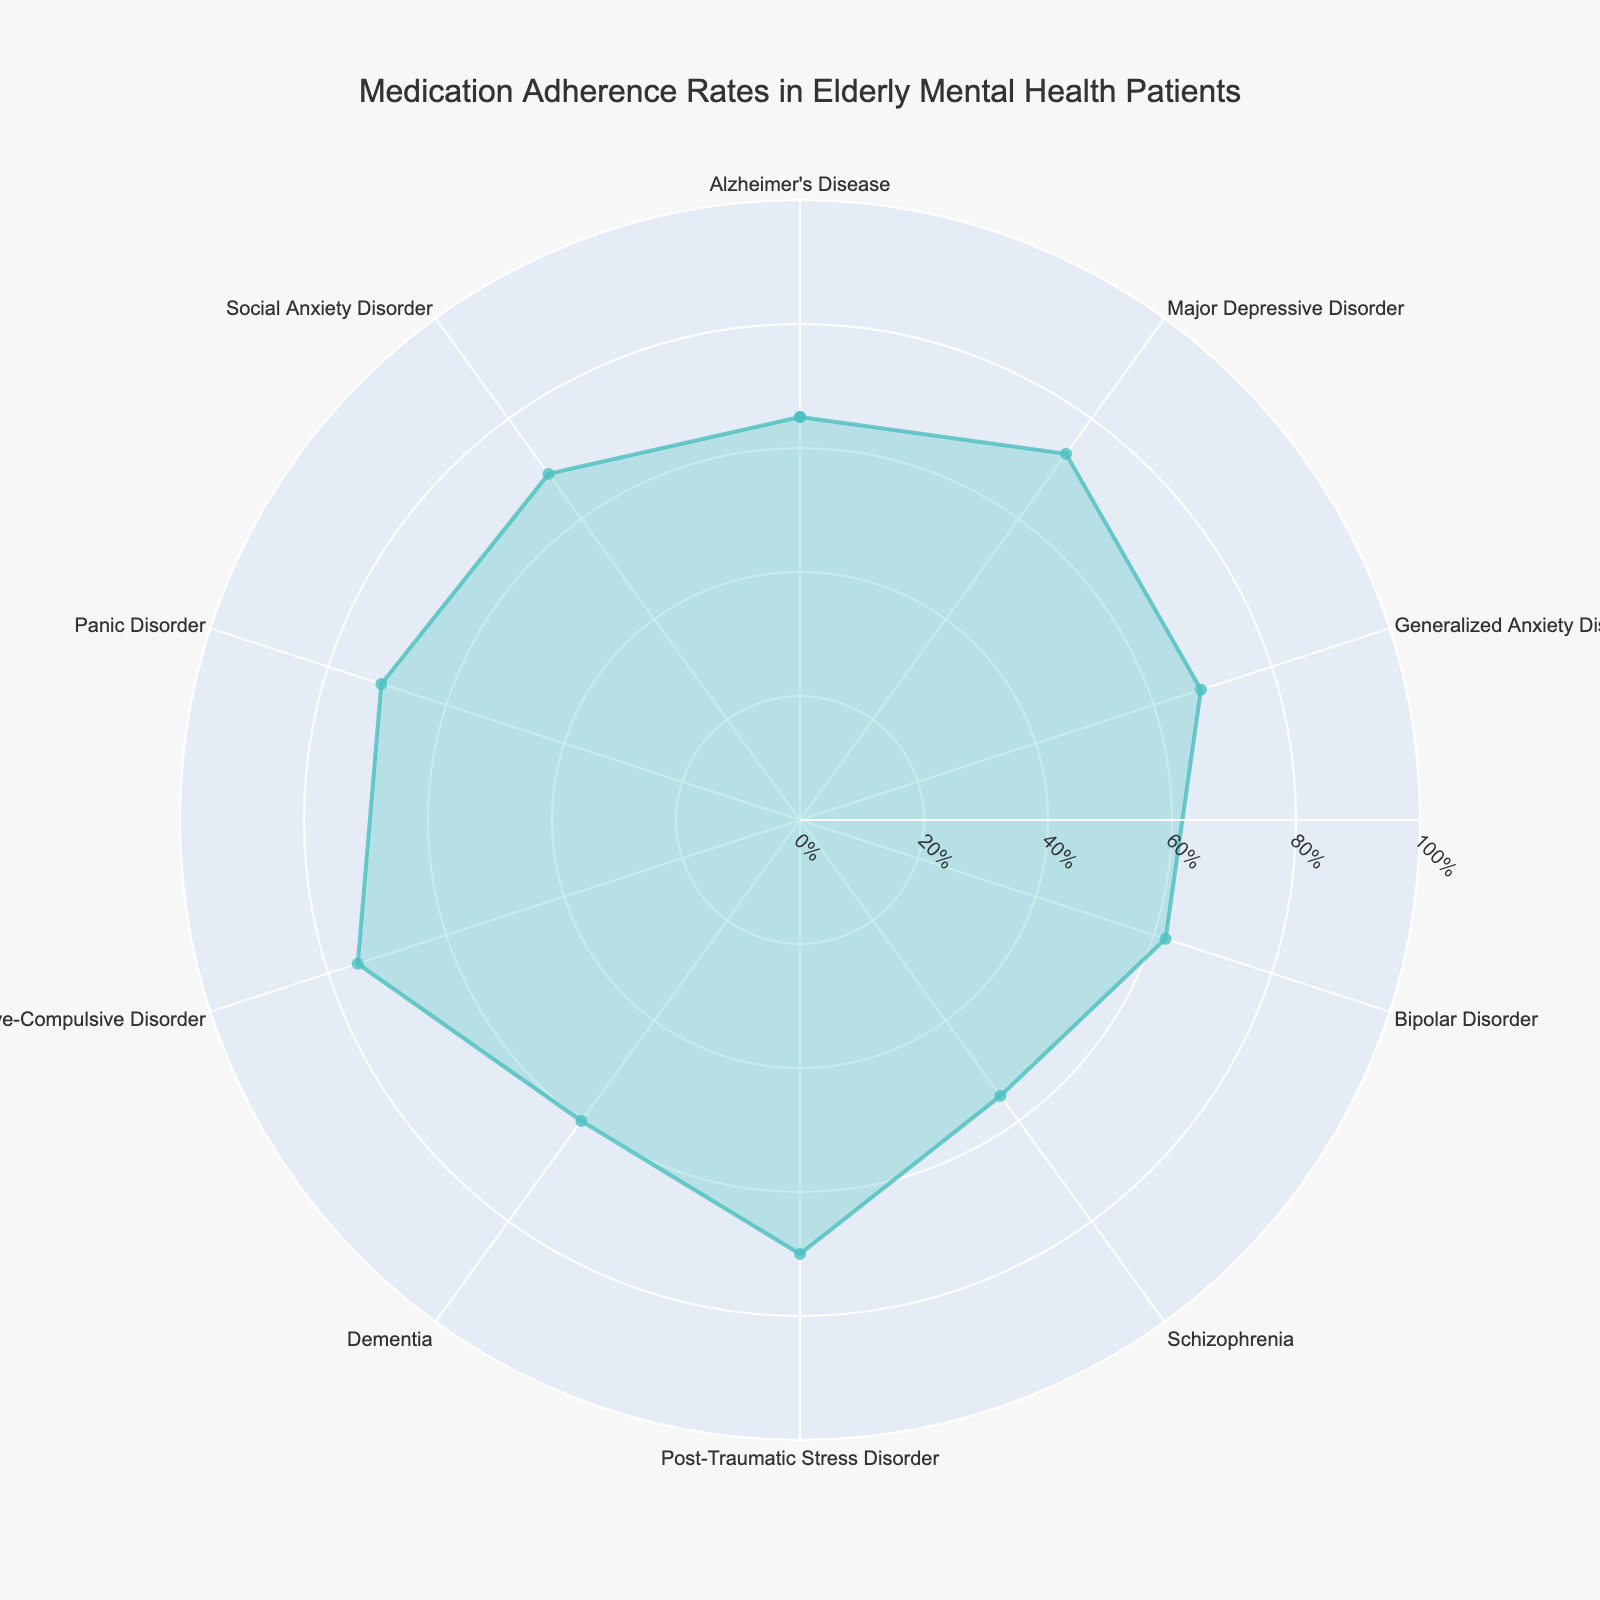What's the diagnosis with the highest medication adherence rate? The rose chart shows the medication adherence rates for different diagnoses. The segment with the highest value reached is Obsessive-Compulsive Disorder, which extends to 75%.
Answer: Obsessive-Compulsive Disorder Which diagnosis has the lowest medication adherence rate? By observing the segments of the chart, the diagnosis with the shortest length is Schizophrenia, indicating it has the lowest adherence rate of 55%.
Answer: Schizophrenia How do the adherence rates for Major Depressive Disorder and Generalized Anxiety Disorder compare? Major Depressive Disorder has an adherence rate of 73%, whereas Generalized Anxiety Disorder has a rate of 68%. By comparing these values, Major Depressive Disorder has a higher adherence rate.
Answer: Major Depressive Disorder is higher What's the average medication adherence rate across all diagnoses? Sum the adherence rates for all diagnoses and divide by the number of diagnoses. (65 + 73 + 68 + 62 + 55 + 70 + 60 + 75 + 71 + 69) / 10 = 668 / 10 = 66.8
Answer: 66.8% Which diagnoses have adherence rates greater than 70%? Observing the chart, the diagnoses with adherence rates extending beyond 70% are Major Depressive Disorder (73%), Post-Traumatic Stress Disorder (70%), Obsessive-Compulsive Disorder (75%), and Panic Disorder (71%).
Answer: Major Depressive Disorder, Obsessive-Compulsive Disorder, Panic Disorder, Post-Traumatic Stress Disorder What's the range of medication adherence rates shown in the chart? The range is the difference between the highest and lowest adherence rates. The highest is 75% for Obsessive-Compulsive Disorder, and the lowest is 55% for Schizophrenia. 75% - 55% = 20%
Answer: 20% What is the adherence rate for Alzheimer's Disease? The chart shows that the segment corresponding to Alzheimer's Disease extends to the 65% mark.
Answer: 65% How do the adherence rates for Bipolar Disorder and Dementia compare? Bipolar Disorder has an adherence rate of 62%, and Dementia has a rate of 60%. By comparing these values, Bipolar Disorder has a slightly higher adherence rate.
Answer: Bipolar Disorder is higher Which diagnosis is closest in adherence rate to Social Anxiety Disorder? Social Anxiety Disorder has a rate of 69%, and the closest diagnosis is Generalized Anxiety Disorder with a rate of 68%, which is just 1% difference.
Answer: Generalized Anxiety Disorder What's the median medication adherence rate? To find the median, first arrange the adherence rates in ascending order: 55, 60, 62, 65, 68, 69, 70, 71, 73, 75. The median is the middle value or the average of the two middle values. (68 + 69) / 2 = 68.5
Answer: 68.5% 